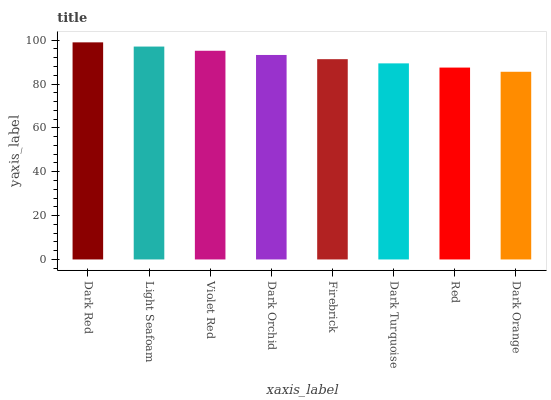Is Light Seafoam the minimum?
Answer yes or no. No. Is Light Seafoam the maximum?
Answer yes or no. No. Is Dark Red greater than Light Seafoam?
Answer yes or no. Yes. Is Light Seafoam less than Dark Red?
Answer yes or no. Yes. Is Light Seafoam greater than Dark Red?
Answer yes or no. No. Is Dark Red less than Light Seafoam?
Answer yes or no. No. Is Dark Orchid the high median?
Answer yes or no. Yes. Is Firebrick the low median?
Answer yes or no. Yes. Is Firebrick the high median?
Answer yes or no. No. Is Light Seafoam the low median?
Answer yes or no. No. 